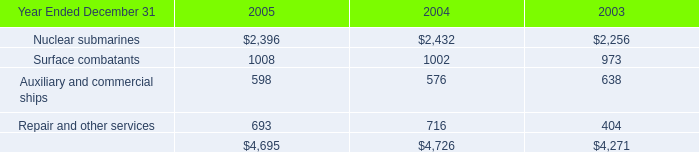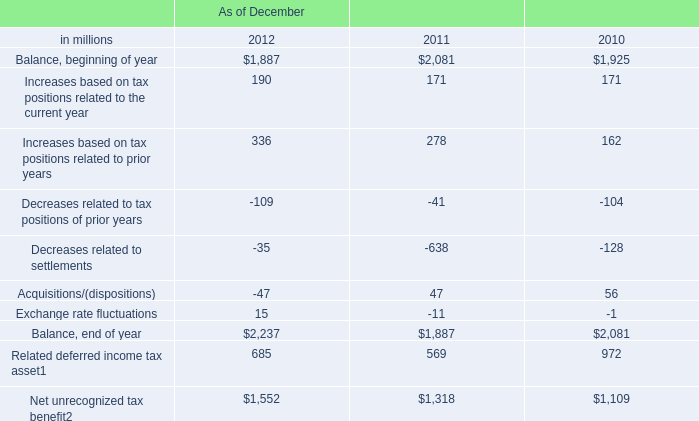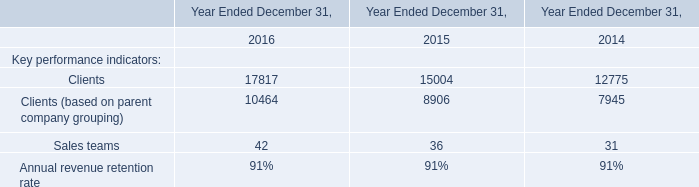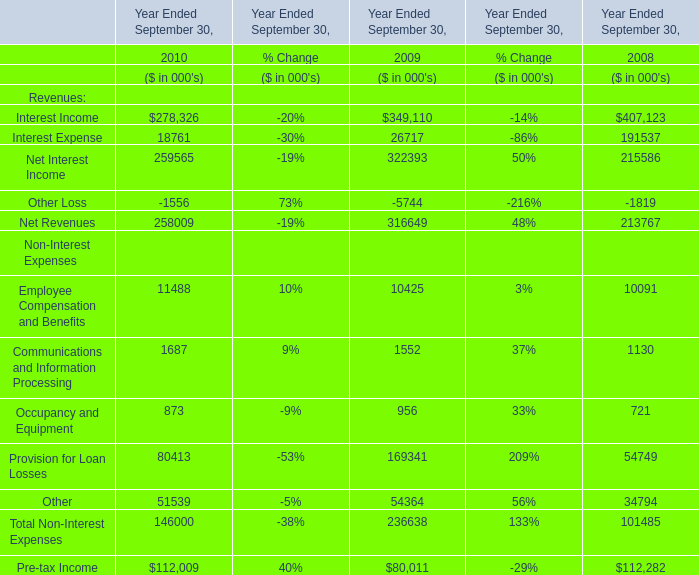What is the percentage of all Net Interest Income that are positive to the total amount, in 2010 and 2009? 
Computations: ((259565 + 322393) / ((259565 + 322393) + 215586))
Answer: 0.72969. 